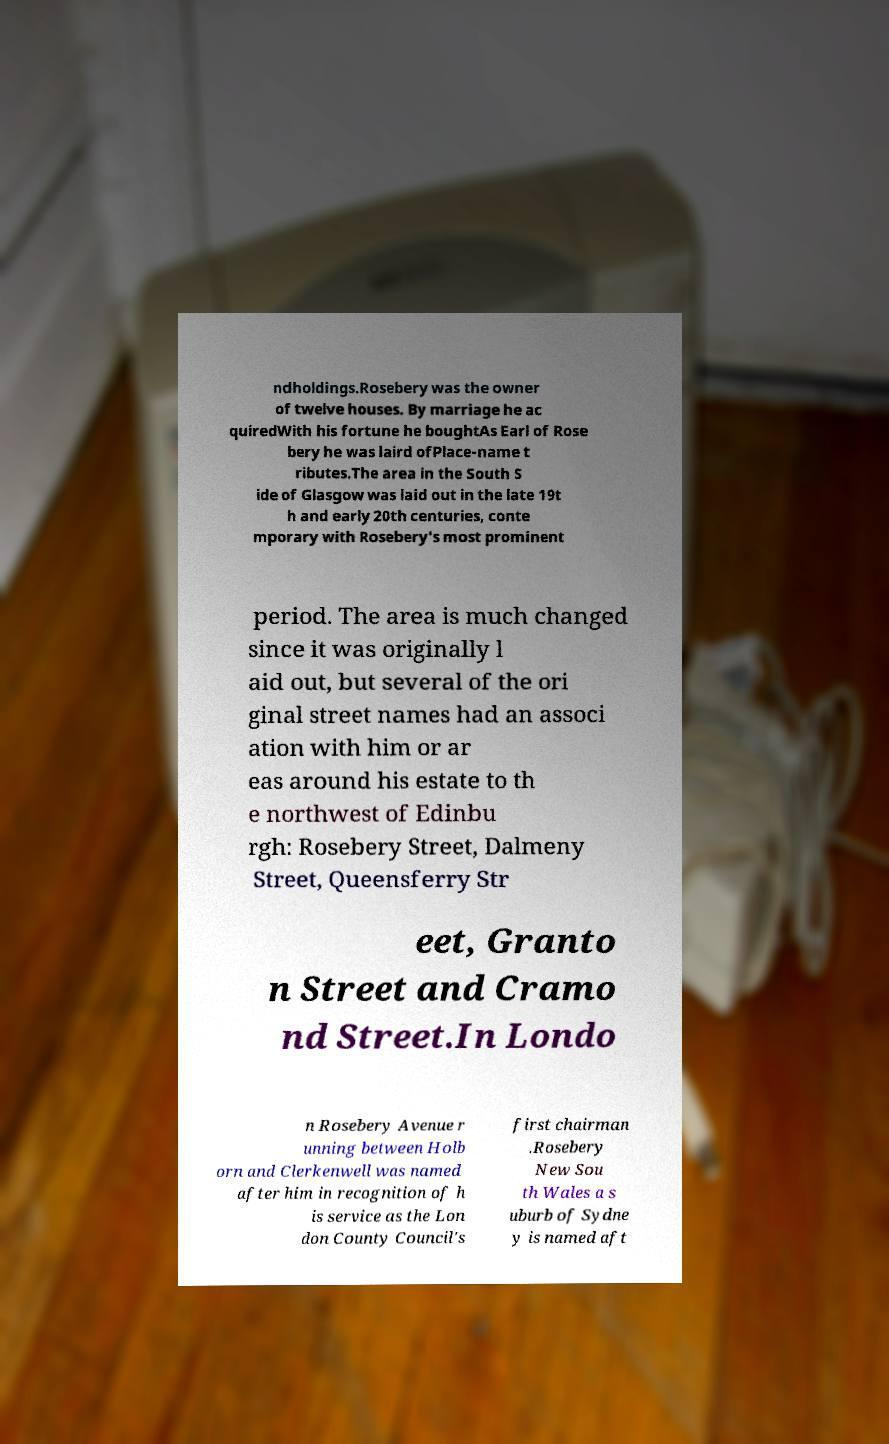There's text embedded in this image that I need extracted. Can you transcribe it verbatim? ndholdings.Rosebery was the owner of twelve houses. By marriage he ac quiredWith his fortune he boughtAs Earl of Rose bery he was laird ofPlace-name t ributes.The area in the South S ide of Glasgow was laid out in the late 19t h and early 20th centuries, conte mporary with Rosebery's most prominent period. The area is much changed since it was originally l aid out, but several of the ori ginal street names had an associ ation with him or ar eas around his estate to th e northwest of Edinbu rgh: Rosebery Street, Dalmeny Street, Queensferry Str eet, Granto n Street and Cramo nd Street.In Londo n Rosebery Avenue r unning between Holb orn and Clerkenwell was named after him in recognition of h is service as the Lon don County Council's first chairman .Rosebery New Sou th Wales a s uburb of Sydne y is named aft 